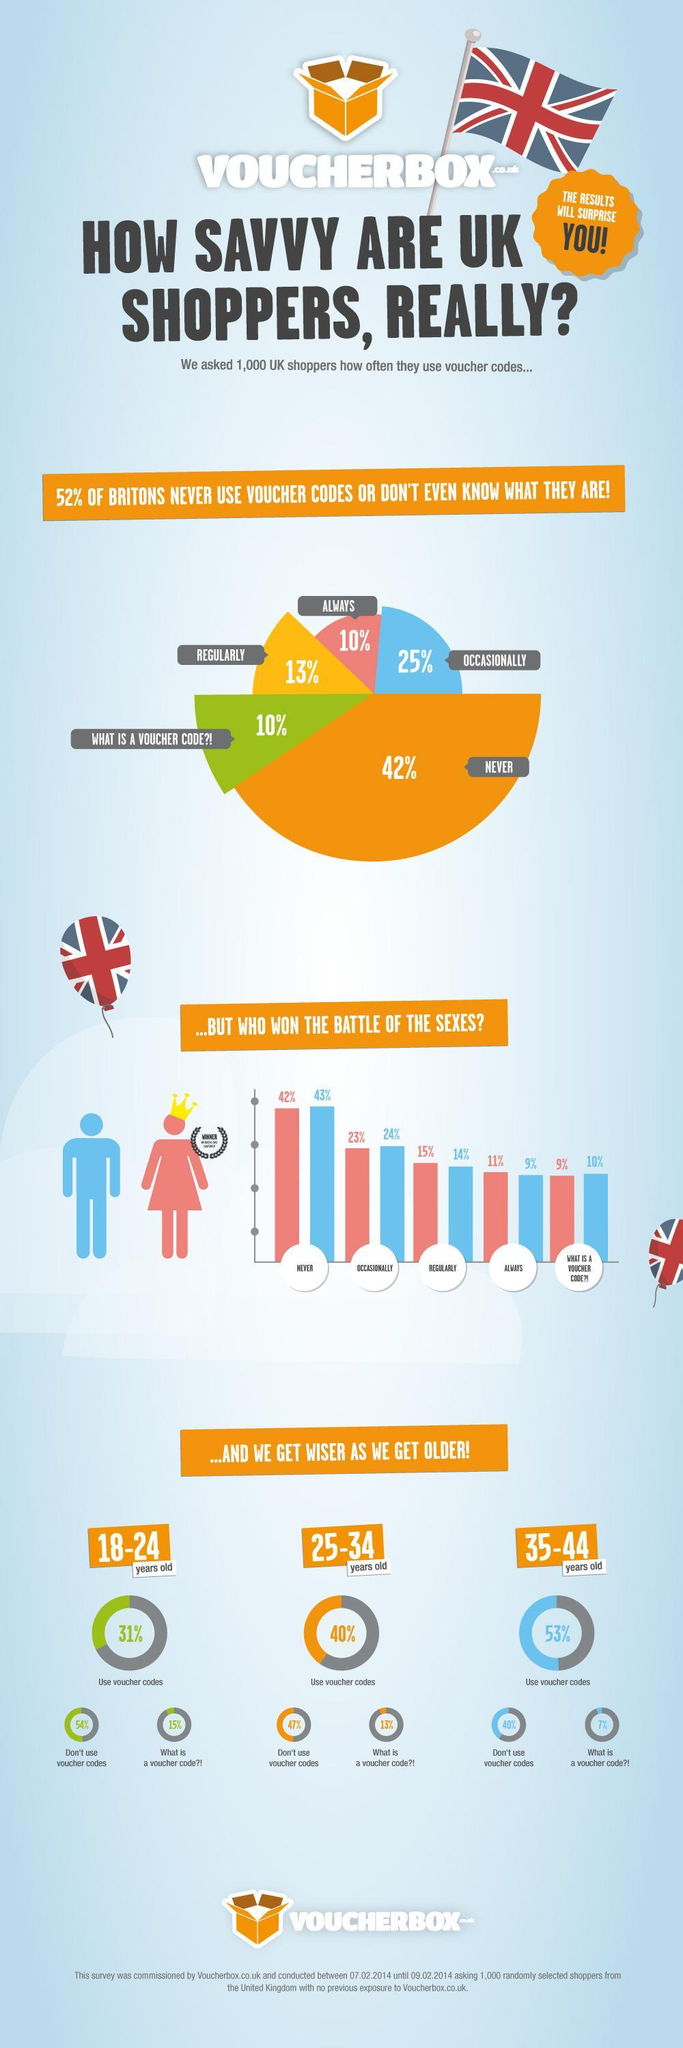What percent of 18-24 years old are not aware of voucher code?
Answer the question with a short phrase. 15% What percent of 35-44 years old do not know what voucher code is? 7% What percent of shoppers use voucher codes regularly, always as well as occasionally? 48% What is the difference in percentage between 25-34 years old who use and don't use voucher codes? 7% Which gender uses voucher codes most- men or women? women 